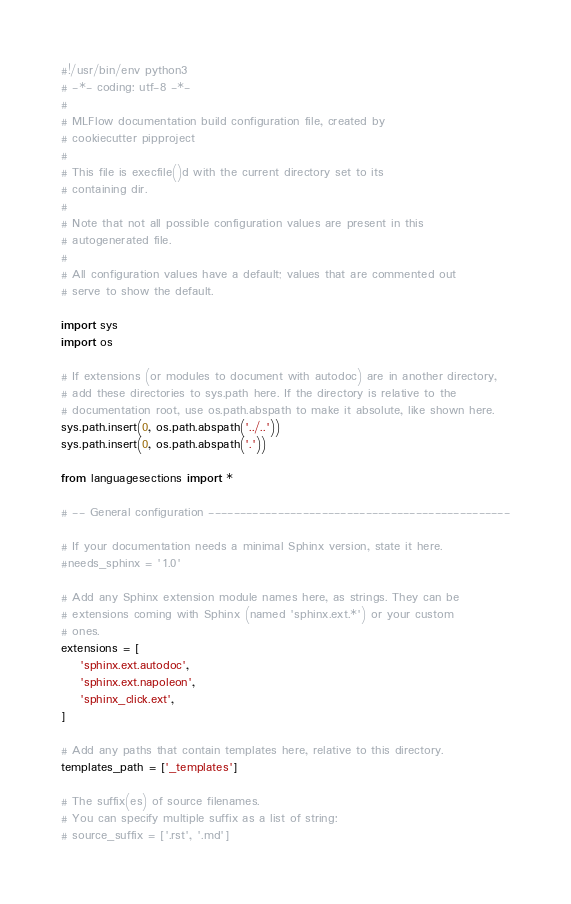Convert code to text. <code><loc_0><loc_0><loc_500><loc_500><_Python_>#!/usr/bin/env python3
# -*- coding: utf-8 -*-
#
# MLFlow documentation build configuration file, created by
# cookiecutter pipproject
#
# This file is execfile()d with the current directory set to its
# containing dir.
#
# Note that not all possible configuration values are present in this
# autogenerated file.
#
# All configuration values have a default; values that are commented out
# serve to show the default.

import sys
import os

# If extensions (or modules to document with autodoc) are in another directory,
# add these directories to sys.path here. If the directory is relative to the
# documentation root, use os.path.abspath to make it absolute, like shown here.
sys.path.insert(0, os.path.abspath('../..'))
sys.path.insert(0, os.path.abspath('.'))

from languagesections import *

# -- General configuration ------------------------------------------------

# If your documentation needs a minimal Sphinx version, state it here.
#needs_sphinx = '1.0'

# Add any Sphinx extension module names here, as strings. They can be
# extensions coming with Sphinx (named 'sphinx.ext.*') or your custom
# ones.
extensions = [
    'sphinx.ext.autodoc',
    'sphinx.ext.napoleon',
    'sphinx_click.ext',
]

# Add any paths that contain templates here, relative to this directory.
templates_path = ['_templates']

# The suffix(es) of source filenames.
# You can specify multiple suffix as a list of string:
# source_suffix = ['.rst', '.md']</code> 